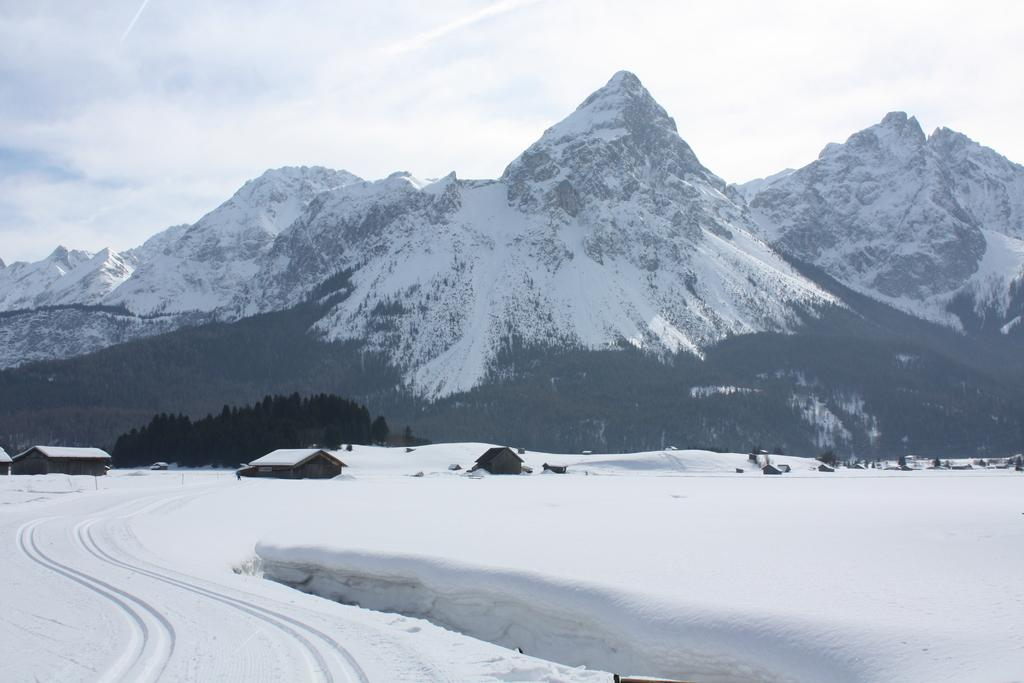What is the main feature in the foreground of the image? There is snow in the foreground of the image. What can be seen in the middle of the image? There are houses and trees in the middle of the image. What is visible at the top of the image? There are mountains and the sky visible at the top of the image. Can you describe the sky in the image? The sky is visible at the top of the image, and there is a cloud visible in the sky. How many rabbits are hopping through the snow in the image? There are no rabbits present in the image; it only features snow in the foreground. What type of coat is the person wearing in the image? There is no person visible in the image, so it is not possible to determine what type of coat they might be wearing. 